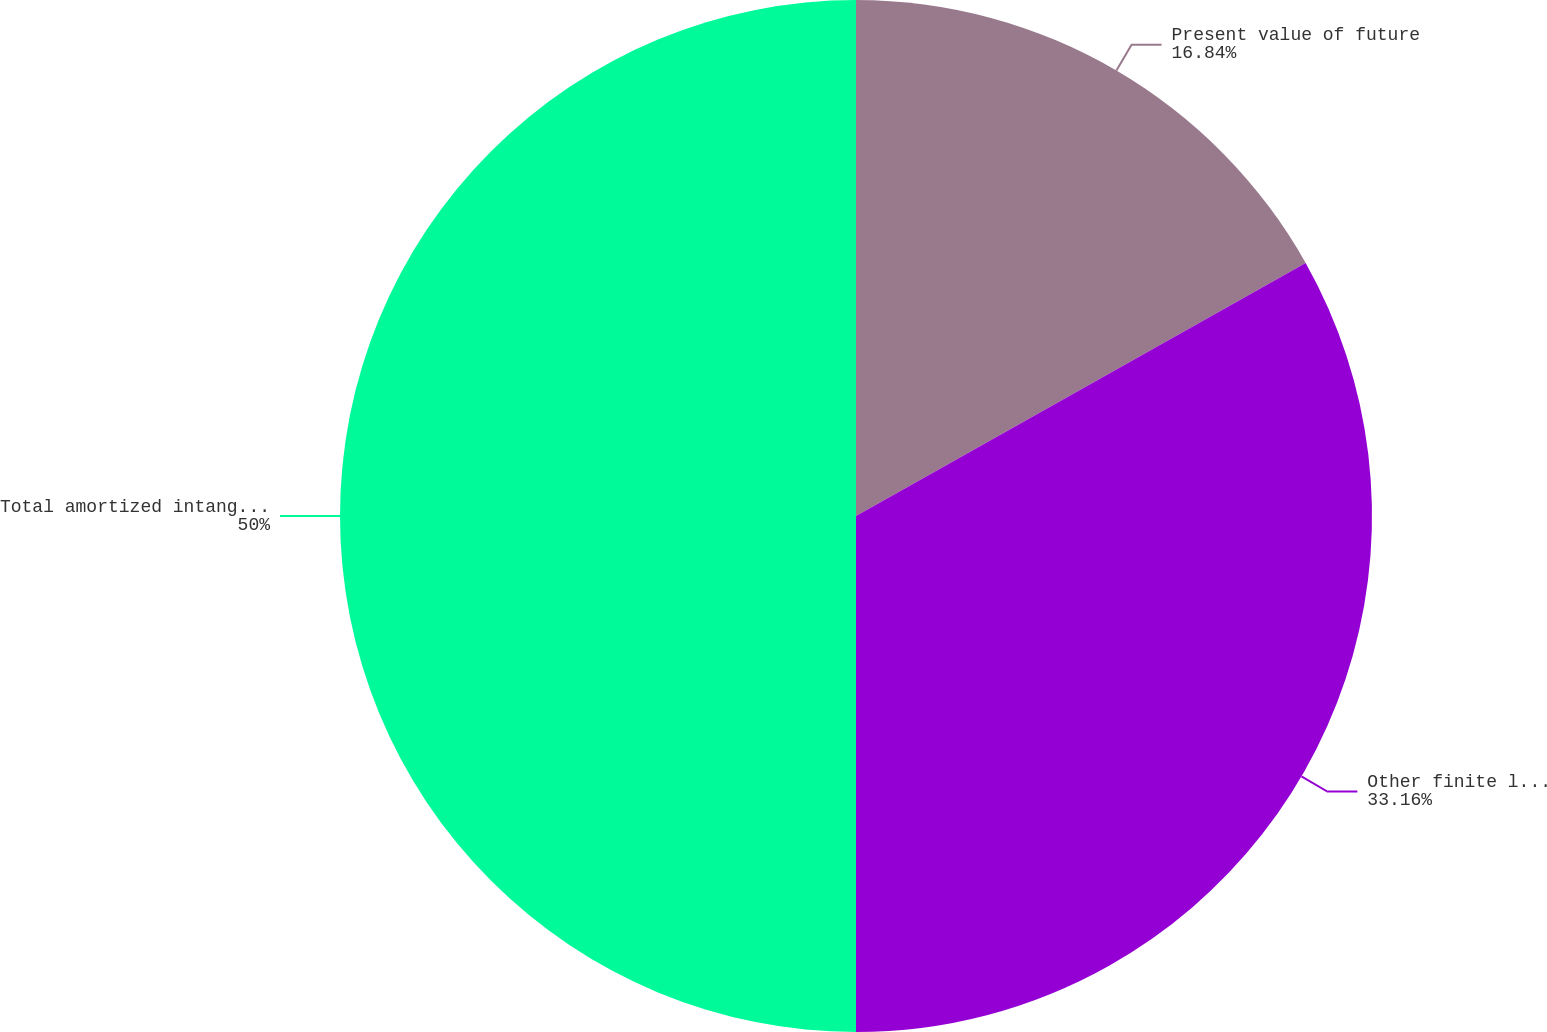Convert chart. <chart><loc_0><loc_0><loc_500><loc_500><pie_chart><fcel>Present value of future<fcel>Other finite lived intangibles<fcel>Total amortized intangibles<nl><fcel>16.84%<fcel>33.16%<fcel>50.0%<nl></chart> 